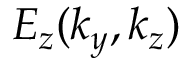Convert formula to latex. <formula><loc_0><loc_0><loc_500><loc_500>E _ { z } ( k _ { y } , k _ { z } )</formula> 